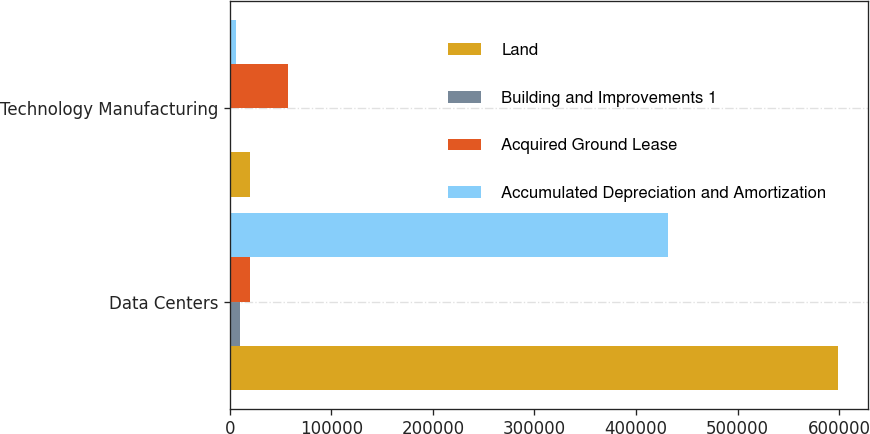Convert chart to OTSL. <chart><loc_0><loc_0><loc_500><loc_500><stacked_bar_chart><ecel><fcel>Data Centers<fcel>Technology Manufacturing<nl><fcel>Land<fcel>598475<fcel>20199<nl><fcel>Building and Improvements 1<fcel>10014<fcel>1321<nl><fcel>Acquired Ground Lease<fcel>20199<fcel>57766<nl><fcel>Accumulated Depreciation and Amortization<fcel>431444<fcel>6333<nl></chart> 